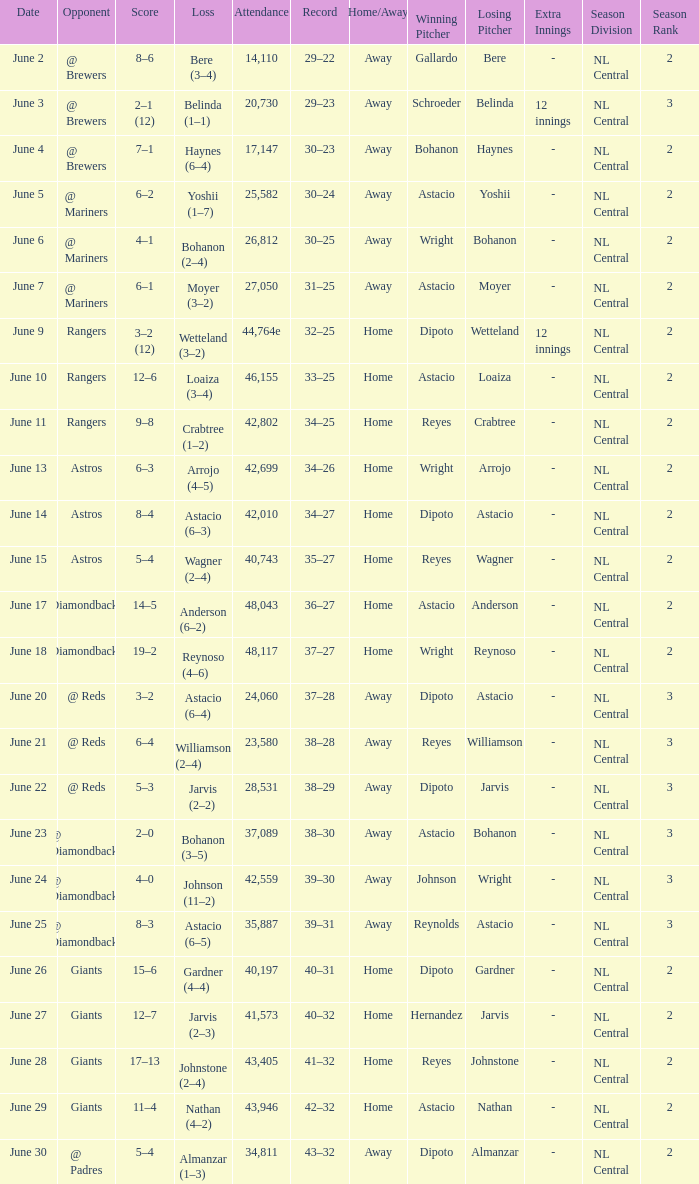What's the record when the attendance was 41,573? 40–32. Parse the table in full. {'header': ['Date', 'Opponent', 'Score', 'Loss', 'Attendance', 'Record', 'Home/Away', 'Winning Pitcher', 'Losing Pitcher', 'Extra Innings', 'Season Division', 'Season Rank'], 'rows': [['June 2', '@ Brewers', '8–6', 'Bere (3–4)', '14,110', '29–22', 'Away', 'Gallardo', 'Bere', '-', 'NL Central', '2'], ['June 3', '@ Brewers', '2–1 (12)', 'Belinda (1–1)', '20,730', '29–23', 'Away', 'Schroeder', 'Belinda', '12 innings', 'NL Central', '3'], ['June 4', '@ Brewers', '7–1', 'Haynes (6–4)', '17,147', '30–23', 'Away', 'Bohanon', 'Haynes', '-', 'NL Central', '2'], ['June 5', '@ Mariners', '6–2', 'Yoshii (1–7)', '25,582', '30–24', 'Away', 'Astacio', 'Yoshii', '-', 'NL Central', '2'], ['June 6', '@ Mariners', '4–1', 'Bohanon (2–4)', '26,812', '30–25', 'Away', 'Wright', 'Bohanon', '-', 'NL Central', '2'], ['June 7', '@ Mariners', '6–1', 'Moyer (3–2)', '27,050', '31–25', 'Away', 'Astacio', 'Moyer', '-', 'NL Central', '2'], ['June 9', 'Rangers', '3–2 (12)', 'Wetteland (3–2)', '44,764e', '32–25', 'Home', 'Dipoto', 'Wetteland', '12 innings', 'NL Central', '2'], ['June 10', 'Rangers', '12–6', 'Loaiza (3–4)', '46,155', '33–25', 'Home', 'Astacio', 'Loaiza', '-', 'NL Central', '2'], ['June 11', 'Rangers', '9–8', 'Crabtree (1–2)', '42,802', '34–25', 'Home', 'Reyes', 'Crabtree', '-', 'NL Central', '2'], ['June 13', 'Astros', '6–3', 'Arrojo (4–5)', '42,699', '34–26', 'Home', 'Wright', 'Arrojo', '-', 'NL Central', '2'], ['June 14', 'Astros', '8–4', 'Astacio (6–3)', '42,010', '34–27', 'Home', 'Dipoto', 'Astacio', '-', 'NL Central', '2'], ['June 15', 'Astros', '5–4', 'Wagner (2–4)', '40,743', '35–27', 'Home', 'Reyes', 'Wagner', '-', 'NL Central', '2'], ['June 17', 'Diamondbacks', '14–5', 'Anderson (6–2)', '48,043', '36–27', 'Home', 'Astacio', 'Anderson', '-', 'NL Central', '2'], ['June 18', 'Diamondbacks', '19–2', 'Reynoso (4–6)', '48,117', '37–27', 'Home', 'Wright', 'Reynoso', '-', 'NL Central', '2'], ['June 20', '@ Reds', '3–2', 'Astacio (6–4)', '24,060', '37–28', 'Away', 'Dipoto', 'Astacio', '-', 'NL Central', '3'], ['June 21', '@ Reds', '6–4', 'Williamson (2–4)', '23,580', '38–28', 'Away', 'Reyes', 'Williamson', '-', 'NL Central', '3'], ['June 22', '@ Reds', '5–3', 'Jarvis (2–2)', '28,531', '38–29', 'Away', 'Dipoto', 'Jarvis', '-', 'NL Central', '3'], ['June 23', '@ Diamondbacks', '2–0', 'Bohanon (3–5)', '37,089', '38–30', 'Away', 'Astacio', 'Bohanon', '-', 'NL Central', '3'], ['June 24', '@ Diamondbacks', '4–0', 'Johnson (11–2)', '42,559', '39–30', 'Away', 'Johnson', 'Wright', '-', 'NL Central', '3'], ['June 25', '@ Diamondbacks', '8–3', 'Astacio (6–5)', '35,887', '39–31', 'Away', 'Reynolds', 'Astacio', '-', 'NL Central', '3'], ['June 26', 'Giants', '15–6', 'Gardner (4–4)', '40,197', '40–31', 'Home', 'Dipoto', 'Gardner', '-', 'NL Central', '2'], ['June 27', 'Giants', '12–7', 'Jarvis (2–3)', '41,573', '40–32', 'Home', 'Hernandez', 'Jarvis', '-', 'NL Central', '2'], ['June 28', 'Giants', '17–13', 'Johnstone (2–4)', '43,405', '41–32', 'Home', 'Reyes', 'Johnstone', '-', 'NL Central', '2'], ['June 29', 'Giants', '11–4', 'Nathan (4–2)', '43,946', '42–32', 'Home', 'Astacio', 'Nathan', '-', 'NL Central', '2'], ['June 30', '@ Padres', '5–4', 'Almanzar (1–3)', '34,811', '43–32', 'Away', 'Dipoto', 'Almanzar', '-', 'NL Central', '2']]} 